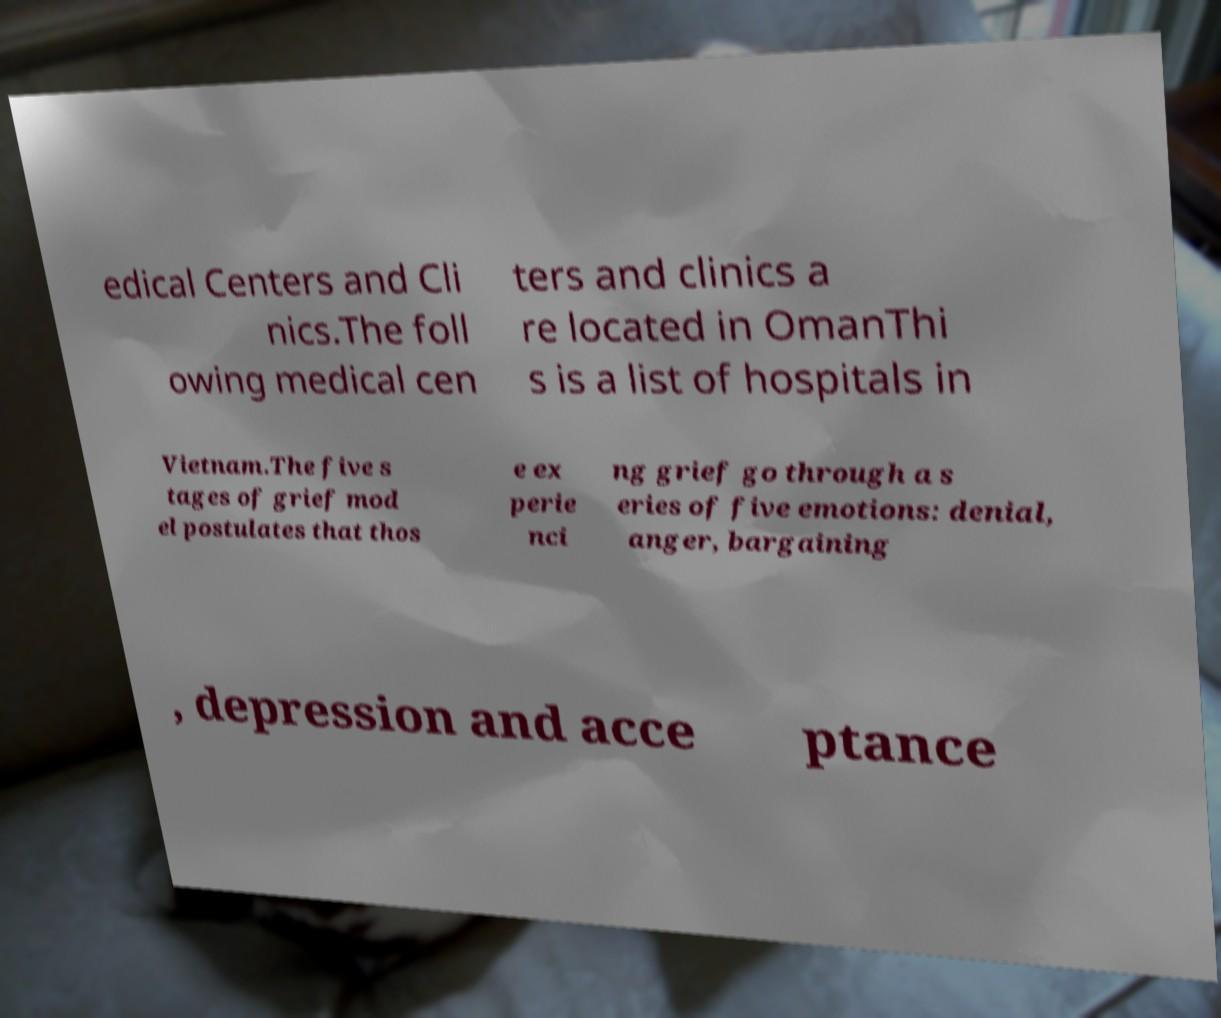Can you accurately transcribe the text from the provided image for me? edical Centers and Cli nics.The foll owing medical cen ters and clinics a re located in OmanThi s is a list of hospitals in Vietnam.The five s tages of grief mod el postulates that thos e ex perie nci ng grief go through a s eries of five emotions: denial, anger, bargaining , depression and acce ptance 